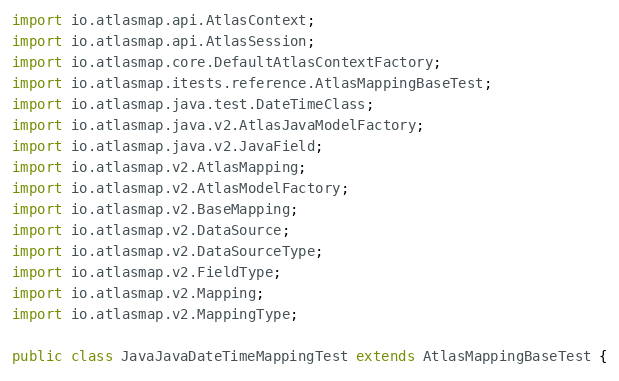<code> <loc_0><loc_0><loc_500><loc_500><_Java_>import io.atlasmap.api.AtlasContext;
import io.atlasmap.api.AtlasSession;
import io.atlasmap.core.DefaultAtlasContextFactory;
import io.atlasmap.itests.reference.AtlasMappingBaseTest;
import io.atlasmap.java.test.DateTimeClass;
import io.atlasmap.java.v2.AtlasJavaModelFactory;
import io.atlasmap.java.v2.JavaField;
import io.atlasmap.v2.AtlasMapping;
import io.atlasmap.v2.AtlasModelFactory;
import io.atlasmap.v2.BaseMapping;
import io.atlasmap.v2.DataSource;
import io.atlasmap.v2.DataSourceType;
import io.atlasmap.v2.FieldType;
import io.atlasmap.v2.Mapping;
import io.atlasmap.v2.MappingType;

public class JavaJavaDateTimeMappingTest extends AtlasMappingBaseTest {</code> 